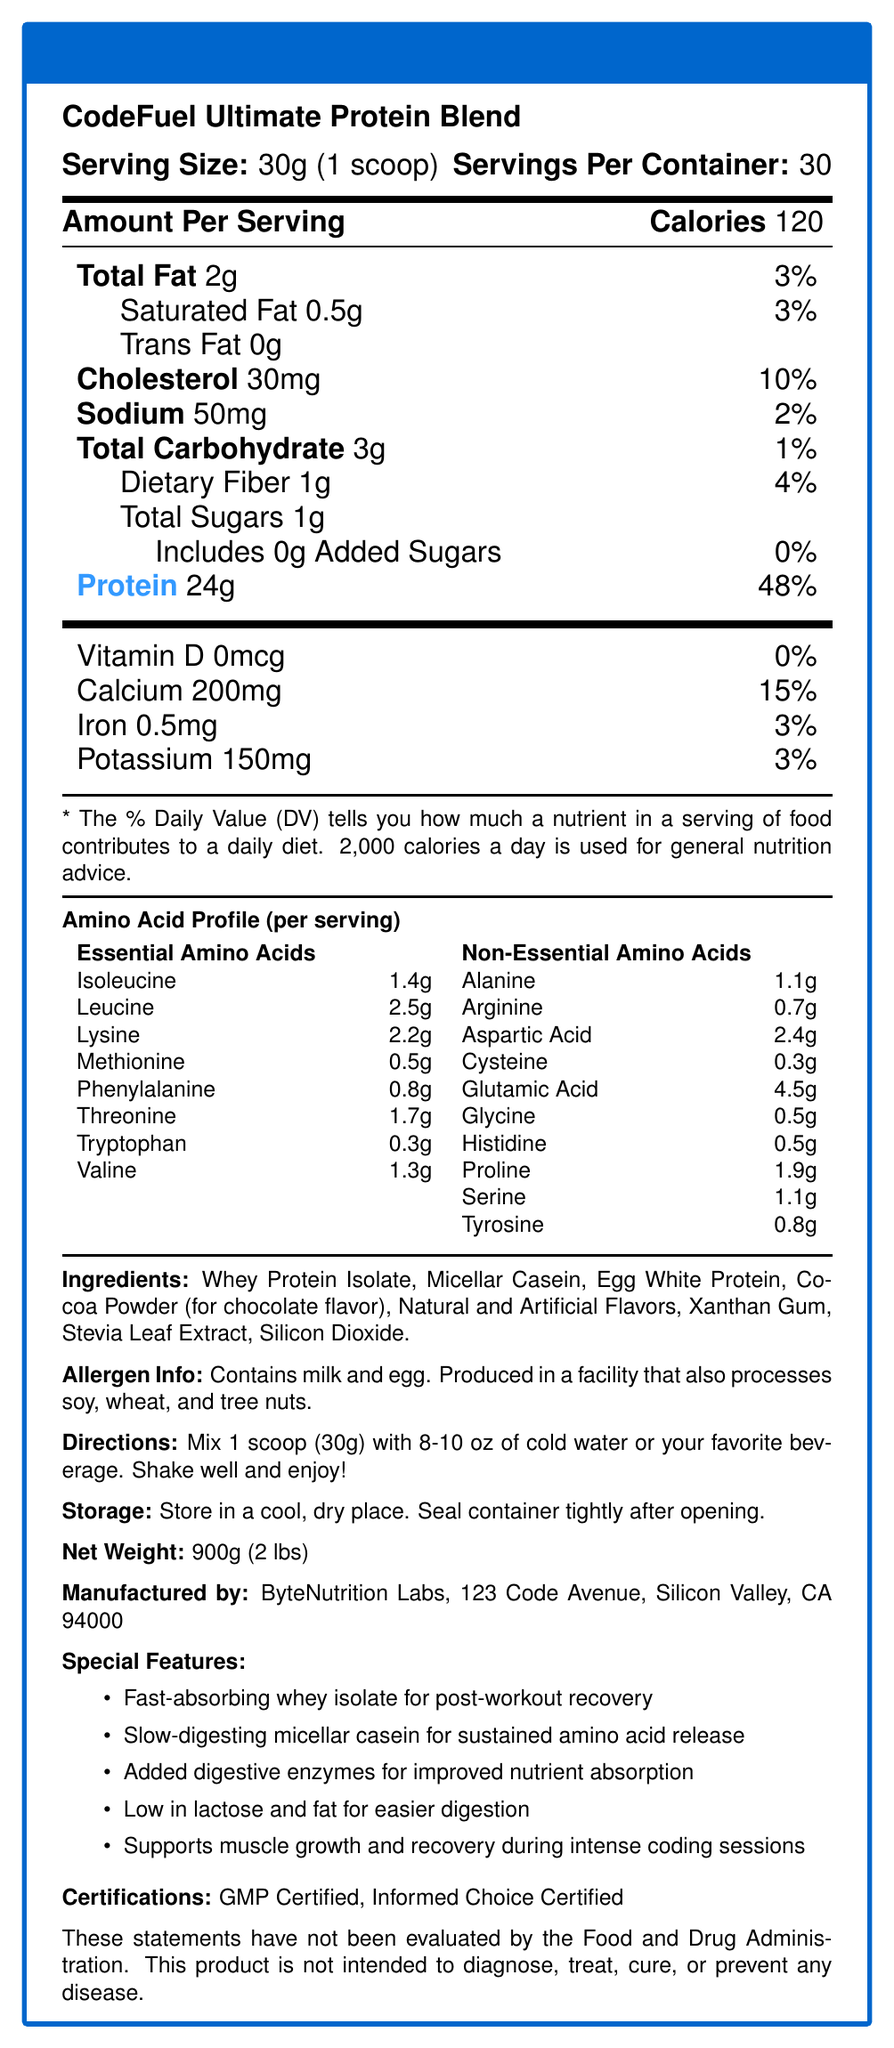what is the serving size of CodeFuel Ultimate Protein Blend? The serving size is explicitly mentioned as "30g (1 scoop)" under the serving information section.
Answer: 30g (1 scoop) How many servings per container are there? The document lists "Servings Per Container: 30" right below the serving size information.
Answer: 30 How many grams of protein are in each serving? The amount of protein per serving is highlighted in blue and listed as "24g" in the nutrition facts.
Answer: 24g What is the calories per serving? The calories per serving are clearly marked as "Calories 120" in the nutrition facts section.
Answer: 120 List the essential amino acids present in the supplement. These amino acids are listed under the "Amino Acid Profile" in the section for Essential Amino Acids.
Answer: Isoleucine, Leucine, Lysine, Methionine, Phenylalanine, Threonine, Tryptophan, Valine Which vitamin or mineral has the highest daily value percentage per serving? Calcium has a daily value of 15%, higher than the other vitamins and minerals listed, which range from 0% to 3%.
Answer: Calcium What is the ratio of BCAAs (Leucine, Isoleucine, Valine) in the protein powder? A. 1:1:1 B. 2:1:1 C. 3:1:1 D. 4:1:2 The document specifies the BCAA ratio as "2:1:1 (Leucine:Isoleucine:Valine)" in the additional information section.
Answer: B. 2:1:1 What are the special features of this protein supplement? A. Low in lactose and fat B. Added digestive enzymes C. Supports muscle growth D. All of the above All three features are listed as benefits under the "Special Features" section.
Answer: D. All of the above Does the product contain any added sugars? The nutrition facts state that there are 0g of added sugars.
Answer: No Summarize the main idea of the document. This summary captures the main sections and highlights provided in the document, including the nutritional values, ingredients, amino acid profile, and other product details.
Answer: The Nutrition Facts label describes the nutritional content, serving information, ingredient list, allergen info, and special features of the CodeFuel Ultimate Protein Blend protein powder. It highlights key attributes like high protein content per serving, a detailed amino acid profile, and low amounts of fat and sugars. Additionally, it lists the product’s certifications and provides usage directions and storage instructions. What is the net weight of the product? The net weight is specified as "900g (2 lbs)" under the storage and directions sections.
Answer: 900g (2 lbs) What company manufactures CodeFuel Ultimate Protein Blend? The manufacturer's name "ByteNutrition Labs" is listed towards the bottom of the nutrition facts box.
Answer: ByteNutrition Labs Does the document specify whether it is gluten-free? The document details allergen information about milk, egg, soy, wheat, and tree nuts but does not specifically mention whether the product is gluten-free.
Answer: Not enough information Which ingredient is used for chocolate flavor? A. Cocoa Powder B. Stevia Leaf Extract C. Xanthan Gum The ingredients list mentions "Cocoa Powder (for chocolate flavor)" specifically for chocolate flavor.
Answer: A. Cocoa Powder What is the address of the manufacturer? This is listed under the manufacturer information towards the end of the document.
Answer: 123 Code Avenue, Silicon Valley, CA 94000 Which flavor options are available? The flavor options are listed at the end of the key product information.
Answer: Vanilla Byte, Chocolate Chip, Strawberry String What certifications does this product hold? The document lists these certifications toward the end under the "Certifications" section.
Answer: GMP Certified, Informed Choice Certified 